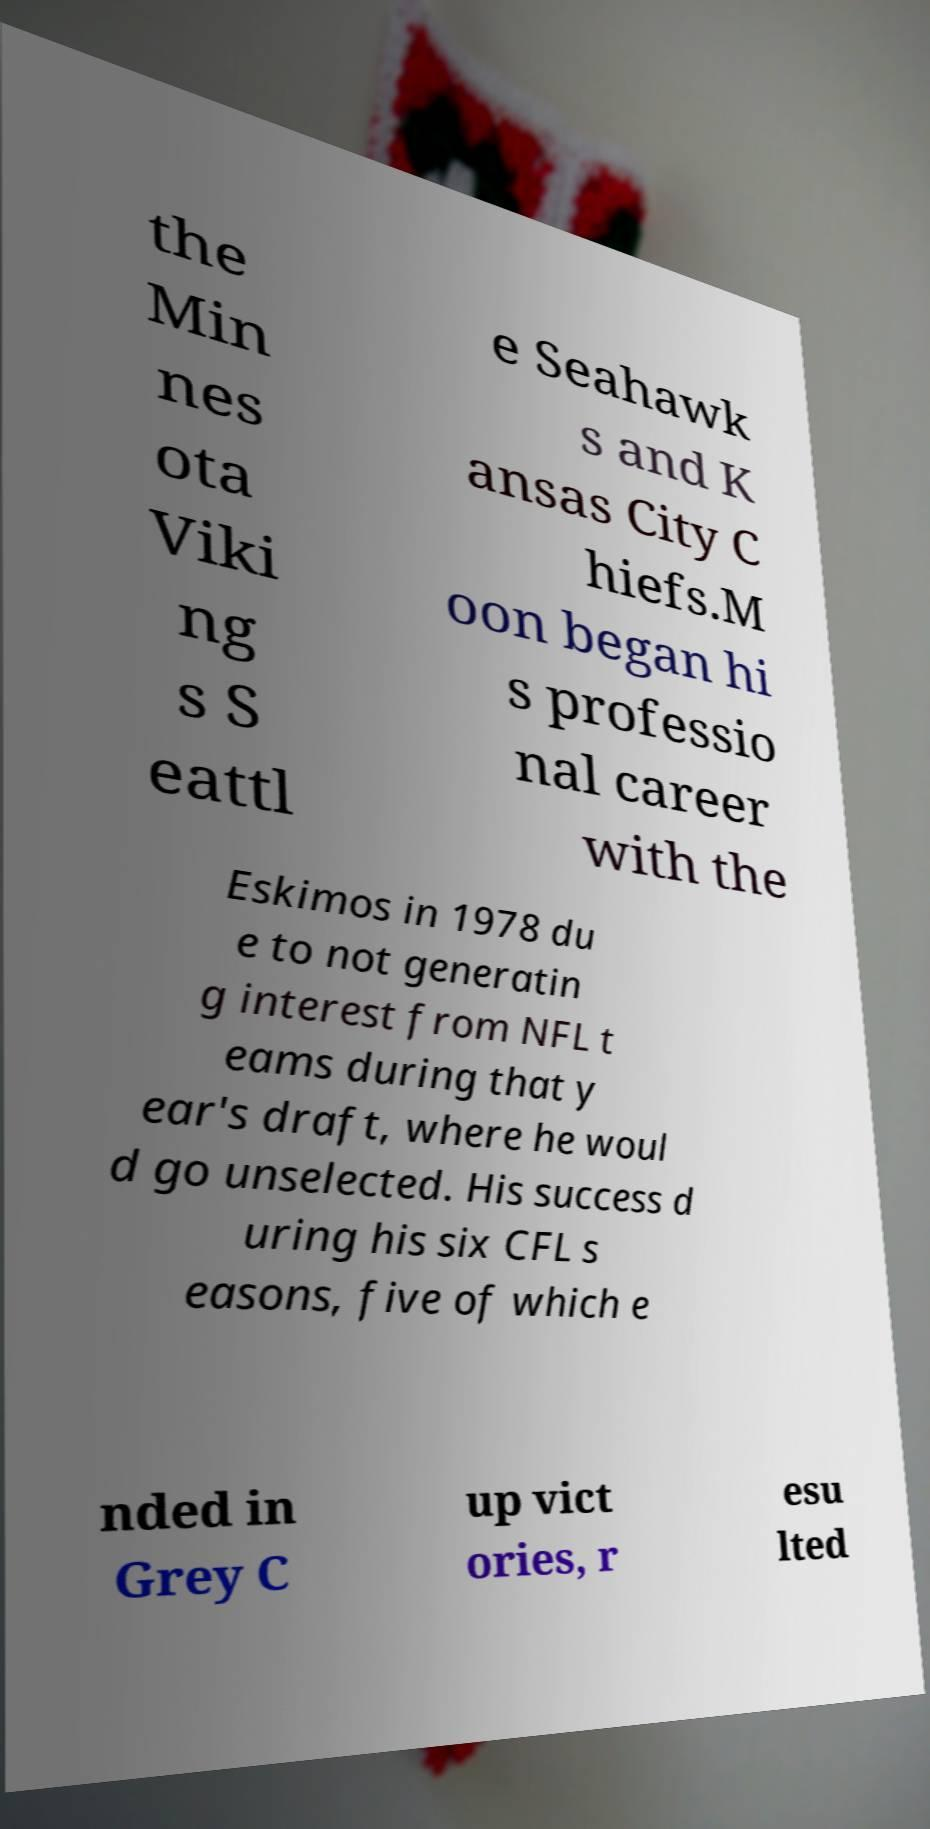What messages or text are displayed in this image? I need them in a readable, typed format. the Min nes ota Viki ng s S eattl e Seahawk s and K ansas City C hiefs.M oon began hi s professio nal career with the Eskimos in 1978 du e to not generatin g interest from NFL t eams during that y ear's draft, where he woul d go unselected. His success d uring his six CFL s easons, five of which e nded in Grey C up vict ories, r esu lted 